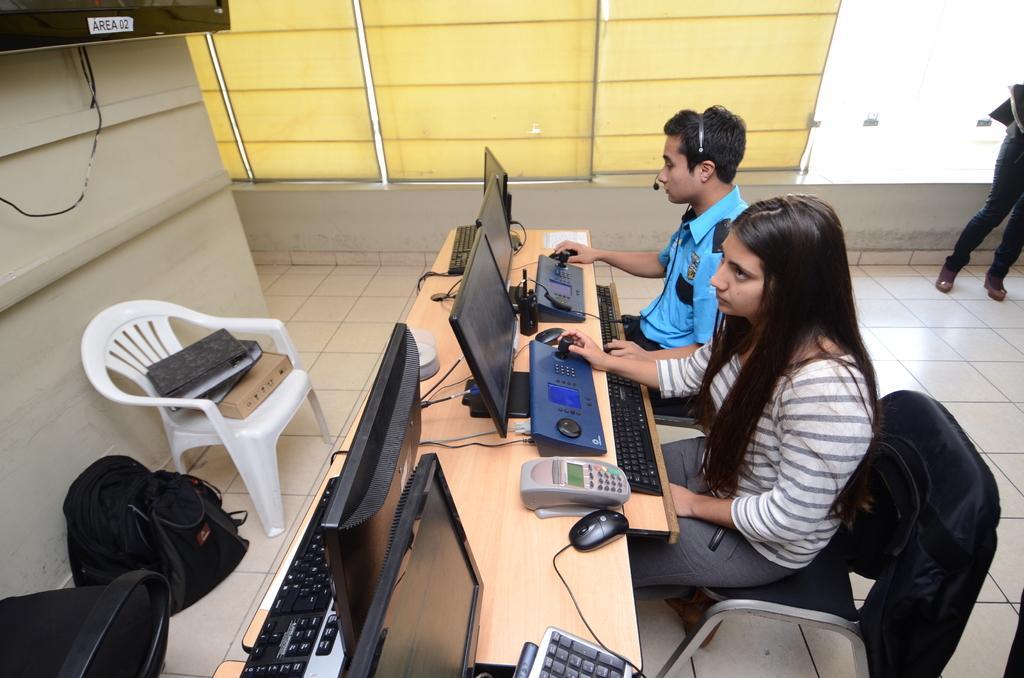How would you summarize this image in a sentence or two? In this image I can see two people sitting on the chairs. One person is wearing the blue shirt and another one with grey color. In front of them there are systems on the table and a machine. To the left there is a chair and some books on the chair. There is a bag on the floor. and also a screen to the wall. In the back there is another person standing. 